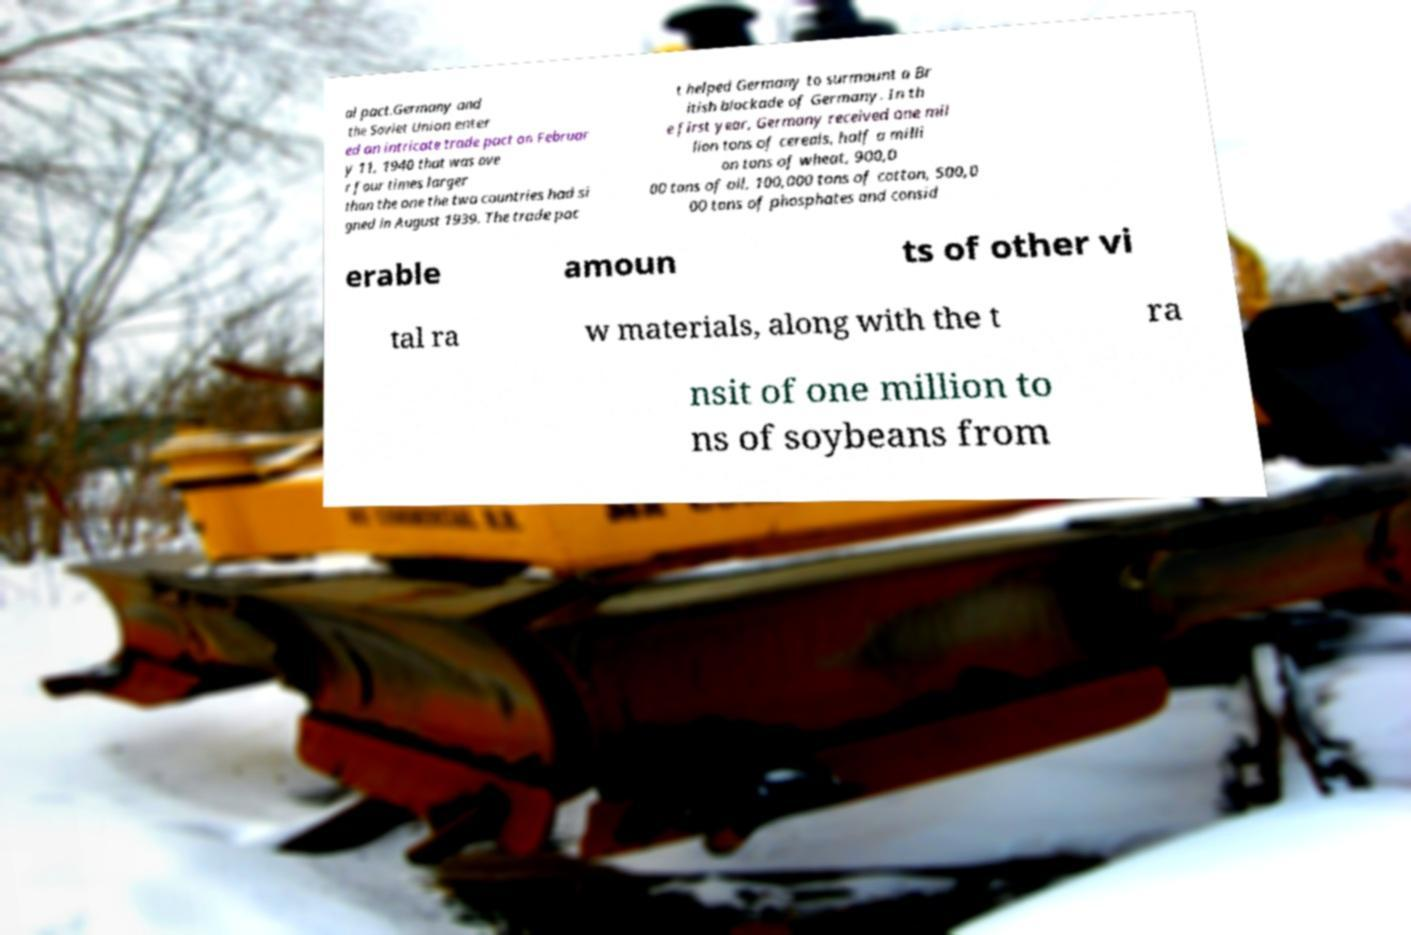Could you assist in decoding the text presented in this image and type it out clearly? al pact.Germany and the Soviet Union enter ed an intricate trade pact on Februar y 11, 1940 that was ove r four times larger than the one the two countries had si gned in August 1939. The trade pac t helped Germany to surmount a Br itish blockade of Germany. In th e first year, Germany received one mil lion tons of cereals, half a milli on tons of wheat, 900,0 00 tons of oil, 100,000 tons of cotton, 500,0 00 tons of phosphates and consid erable amoun ts of other vi tal ra w materials, along with the t ra nsit of one million to ns of soybeans from 